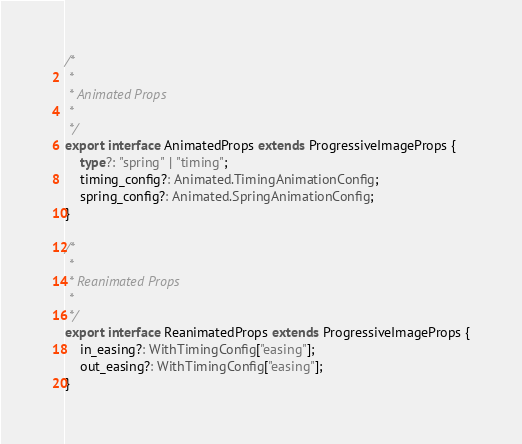<code> <loc_0><loc_0><loc_500><loc_500><_TypeScript_>
/*
 *
 * Animated Props
 *
 */
export interface AnimatedProps extends ProgressiveImageProps {
    type?: "spring" | "timing";
    timing_config?: Animated.TimingAnimationConfig;
    spring_config?: Animated.SpringAnimationConfig;
}

/*
 *
 * Reanimated Props
 *
 */
export interface ReanimatedProps extends ProgressiveImageProps {
    in_easing?: WithTimingConfig["easing"];
    out_easing?: WithTimingConfig["easing"];
}
</code> 